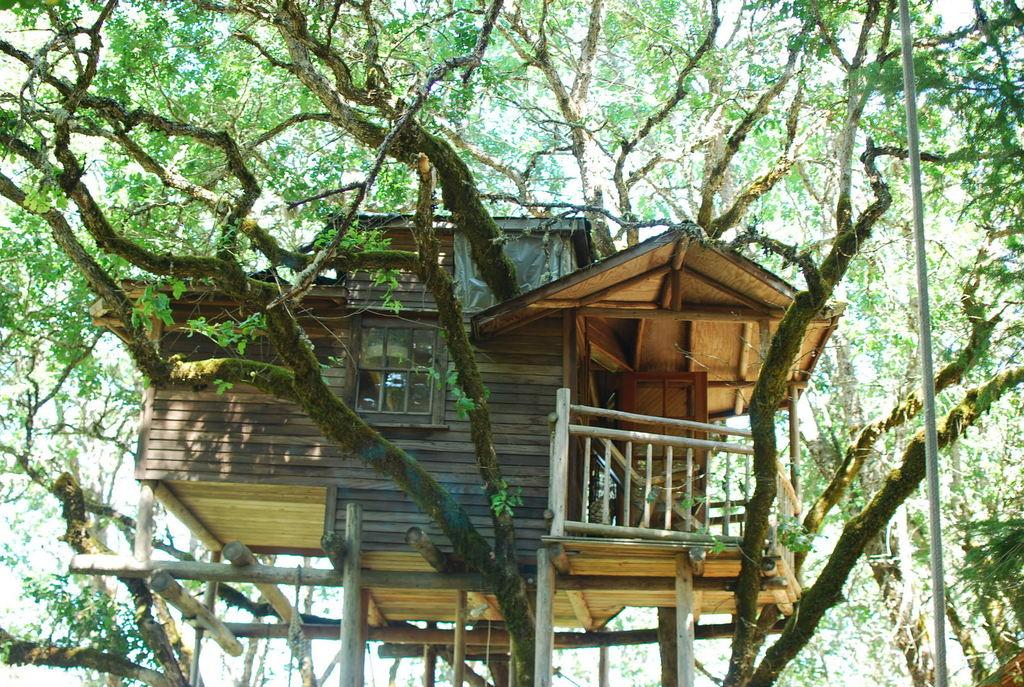What is located in the front of the image? There is a pole in the front of the image. What can be seen in the center of the image? There is a tree house in the center of the image. What type of vegetation is visible in the background of the image? There are trees in the background of the image. How many shoes can be seen hanging from the tree house in the image? There are no shoes visible in the image; it features a pole, a tree house, and trees. What type of coastline is visible in the image? There is no coastline present in the image. 